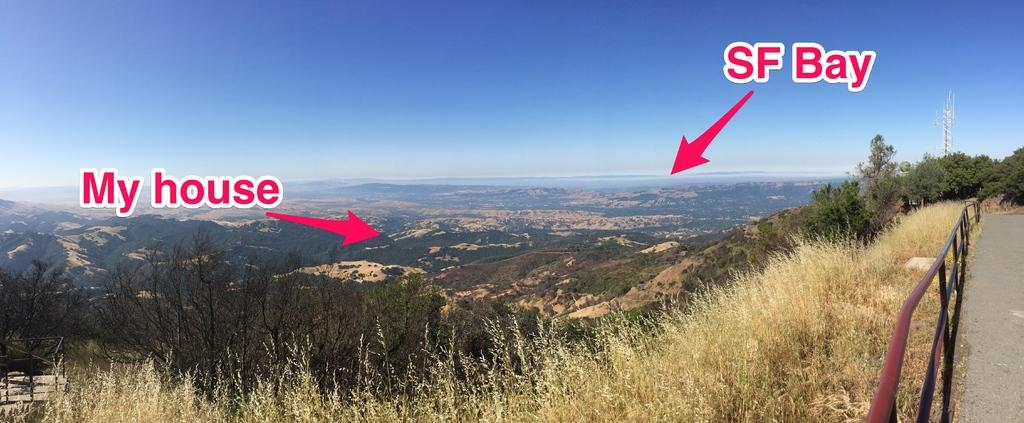<image>
Create a compact narrative representing the image presented. A picture showing the proximity of someone's house from the SF Bay 